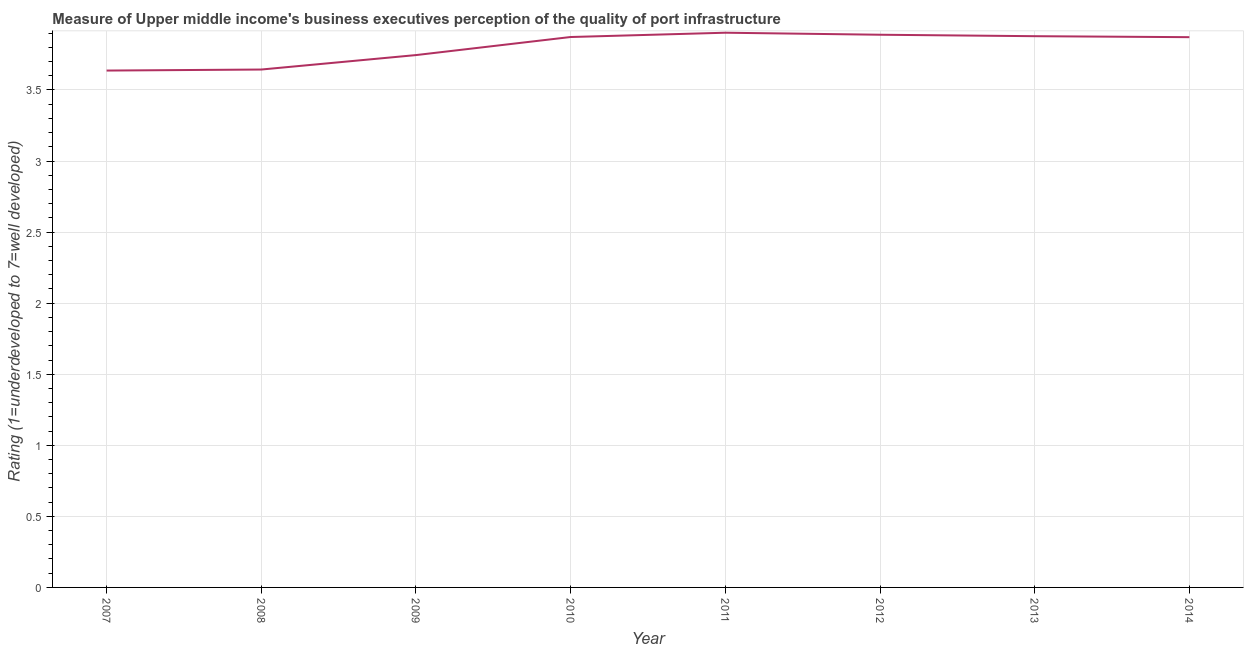What is the rating measuring quality of port infrastructure in 2012?
Your answer should be compact. 3.89. Across all years, what is the maximum rating measuring quality of port infrastructure?
Your answer should be very brief. 3.9. Across all years, what is the minimum rating measuring quality of port infrastructure?
Ensure brevity in your answer.  3.64. In which year was the rating measuring quality of port infrastructure maximum?
Your response must be concise. 2011. In which year was the rating measuring quality of port infrastructure minimum?
Give a very brief answer. 2007. What is the sum of the rating measuring quality of port infrastructure?
Your answer should be very brief. 30.44. What is the difference between the rating measuring quality of port infrastructure in 2007 and 2010?
Ensure brevity in your answer.  -0.24. What is the average rating measuring quality of port infrastructure per year?
Offer a very short reply. 3.8. What is the median rating measuring quality of port infrastructure?
Your answer should be very brief. 3.87. Do a majority of the years between 2010 and 2011 (inclusive) have rating measuring quality of port infrastructure greater than 1.4 ?
Your answer should be compact. Yes. What is the ratio of the rating measuring quality of port infrastructure in 2009 to that in 2012?
Keep it short and to the point. 0.96. Is the rating measuring quality of port infrastructure in 2007 less than that in 2012?
Provide a succinct answer. Yes. What is the difference between the highest and the second highest rating measuring quality of port infrastructure?
Give a very brief answer. 0.01. What is the difference between the highest and the lowest rating measuring quality of port infrastructure?
Your answer should be very brief. 0.27. In how many years, is the rating measuring quality of port infrastructure greater than the average rating measuring quality of port infrastructure taken over all years?
Ensure brevity in your answer.  5. How many lines are there?
Provide a succinct answer. 1. How many years are there in the graph?
Ensure brevity in your answer.  8. Are the values on the major ticks of Y-axis written in scientific E-notation?
Keep it short and to the point. No. Does the graph contain grids?
Your answer should be very brief. Yes. What is the title of the graph?
Offer a terse response. Measure of Upper middle income's business executives perception of the quality of port infrastructure. What is the label or title of the X-axis?
Offer a very short reply. Year. What is the label or title of the Y-axis?
Ensure brevity in your answer.  Rating (1=underdeveloped to 7=well developed) . What is the Rating (1=underdeveloped to 7=well developed)  of 2007?
Keep it short and to the point. 3.64. What is the Rating (1=underdeveloped to 7=well developed)  in 2008?
Provide a succinct answer. 3.64. What is the Rating (1=underdeveloped to 7=well developed)  in 2009?
Your answer should be very brief. 3.75. What is the Rating (1=underdeveloped to 7=well developed)  of 2010?
Your answer should be very brief. 3.87. What is the Rating (1=underdeveloped to 7=well developed)  in 2011?
Offer a very short reply. 3.9. What is the Rating (1=underdeveloped to 7=well developed)  of 2012?
Give a very brief answer. 3.89. What is the Rating (1=underdeveloped to 7=well developed)  in 2013?
Offer a very short reply. 3.88. What is the Rating (1=underdeveloped to 7=well developed)  of 2014?
Offer a terse response. 3.87. What is the difference between the Rating (1=underdeveloped to 7=well developed)  in 2007 and 2008?
Your response must be concise. -0.01. What is the difference between the Rating (1=underdeveloped to 7=well developed)  in 2007 and 2009?
Your answer should be compact. -0.11. What is the difference between the Rating (1=underdeveloped to 7=well developed)  in 2007 and 2010?
Provide a succinct answer. -0.24. What is the difference between the Rating (1=underdeveloped to 7=well developed)  in 2007 and 2011?
Offer a very short reply. -0.27. What is the difference between the Rating (1=underdeveloped to 7=well developed)  in 2007 and 2012?
Make the answer very short. -0.25. What is the difference between the Rating (1=underdeveloped to 7=well developed)  in 2007 and 2013?
Offer a terse response. -0.24. What is the difference between the Rating (1=underdeveloped to 7=well developed)  in 2007 and 2014?
Your answer should be very brief. -0.23. What is the difference between the Rating (1=underdeveloped to 7=well developed)  in 2008 and 2009?
Your answer should be very brief. -0.1. What is the difference between the Rating (1=underdeveloped to 7=well developed)  in 2008 and 2010?
Keep it short and to the point. -0.23. What is the difference between the Rating (1=underdeveloped to 7=well developed)  in 2008 and 2011?
Provide a short and direct response. -0.26. What is the difference between the Rating (1=underdeveloped to 7=well developed)  in 2008 and 2012?
Make the answer very short. -0.24. What is the difference between the Rating (1=underdeveloped to 7=well developed)  in 2008 and 2013?
Your answer should be very brief. -0.23. What is the difference between the Rating (1=underdeveloped to 7=well developed)  in 2008 and 2014?
Give a very brief answer. -0.23. What is the difference between the Rating (1=underdeveloped to 7=well developed)  in 2009 and 2010?
Your answer should be compact. -0.13. What is the difference between the Rating (1=underdeveloped to 7=well developed)  in 2009 and 2011?
Offer a very short reply. -0.16. What is the difference between the Rating (1=underdeveloped to 7=well developed)  in 2009 and 2012?
Your answer should be very brief. -0.14. What is the difference between the Rating (1=underdeveloped to 7=well developed)  in 2009 and 2013?
Provide a succinct answer. -0.13. What is the difference between the Rating (1=underdeveloped to 7=well developed)  in 2009 and 2014?
Offer a terse response. -0.13. What is the difference between the Rating (1=underdeveloped to 7=well developed)  in 2010 and 2011?
Make the answer very short. -0.03. What is the difference between the Rating (1=underdeveloped to 7=well developed)  in 2010 and 2012?
Offer a very short reply. -0.02. What is the difference between the Rating (1=underdeveloped to 7=well developed)  in 2010 and 2013?
Keep it short and to the point. -0.01. What is the difference between the Rating (1=underdeveloped to 7=well developed)  in 2010 and 2014?
Give a very brief answer. 0. What is the difference between the Rating (1=underdeveloped to 7=well developed)  in 2011 and 2012?
Your answer should be compact. 0.01. What is the difference between the Rating (1=underdeveloped to 7=well developed)  in 2011 and 2013?
Give a very brief answer. 0.02. What is the difference between the Rating (1=underdeveloped to 7=well developed)  in 2011 and 2014?
Provide a succinct answer. 0.03. What is the difference between the Rating (1=underdeveloped to 7=well developed)  in 2012 and 2013?
Offer a very short reply. 0.01. What is the difference between the Rating (1=underdeveloped to 7=well developed)  in 2012 and 2014?
Keep it short and to the point. 0.02. What is the difference between the Rating (1=underdeveloped to 7=well developed)  in 2013 and 2014?
Make the answer very short. 0.01. What is the ratio of the Rating (1=underdeveloped to 7=well developed)  in 2007 to that in 2009?
Your answer should be very brief. 0.97. What is the ratio of the Rating (1=underdeveloped to 7=well developed)  in 2007 to that in 2010?
Provide a succinct answer. 0.94. What is the ratio of the Rating (1=underdeveloped to 7=well developed)  in 2007 to that in 2011?
Provide a succinct answer. 0.93. What is the ratio of the Rating (1=underdeveloped to 7=well developed)  in 2007 to that in 2012?
Offer a terse response. 0.94. What is the ratio of the Rating (1=underdeveloped to 7=well developed)  in 2007 to that in 2013?
Your answer should be very brief. 0.94. What is the ratio of the Rating (1=underdeveloped to 7=well developed)  in 2007 to that in 2014?
Offer a very short reply. 0.94. What is the ratio of the Rating (1=underdeveloped to 7=well developed)  in 2008 to that in 2009?
Your answer should be compact. 0.97. What is the ratio of the Rating (1=underdeveloped to 7=well developed)  in 2008 to that in 2010?
Your answer should be compact. 0.94. What is the ratio of the Rating (1=underdeveloped to 7=well developed)  in 2008 to that in 2011?
Provide a short and direct response. 0.93. What is the ratio of the Rating (1=underdeveloped to 7=well developed)  in 2008 to that in 2012?
Your answer should be compact. 0.94. What is the ratio of the Rating (1=underdeveloped to 7=well developed)  in 2008 to that in 2014?
Your answer should be very brief. 0.94. What is the ratio of the Rating (1=underdeveloped to 7=well developed)  in 2009 to that in 2010?
Make the answer very short. 0.97. What is the ratio of the Rating (1=underdeveloped to 7=well developed)  in 2009 to that in 2011?
Ensure brevity in your answer.  0.96. What is the ratio of the Rating (1=underdeveloped to 7=well developed)  in 2009 to that in 2013?
Your response must be concise. 0.97. What is the ratio of the Rating (1=underdeveloped to 7=well developed)  in 2011 to that in 2013?
Provide a short and direct response. 1.01. 